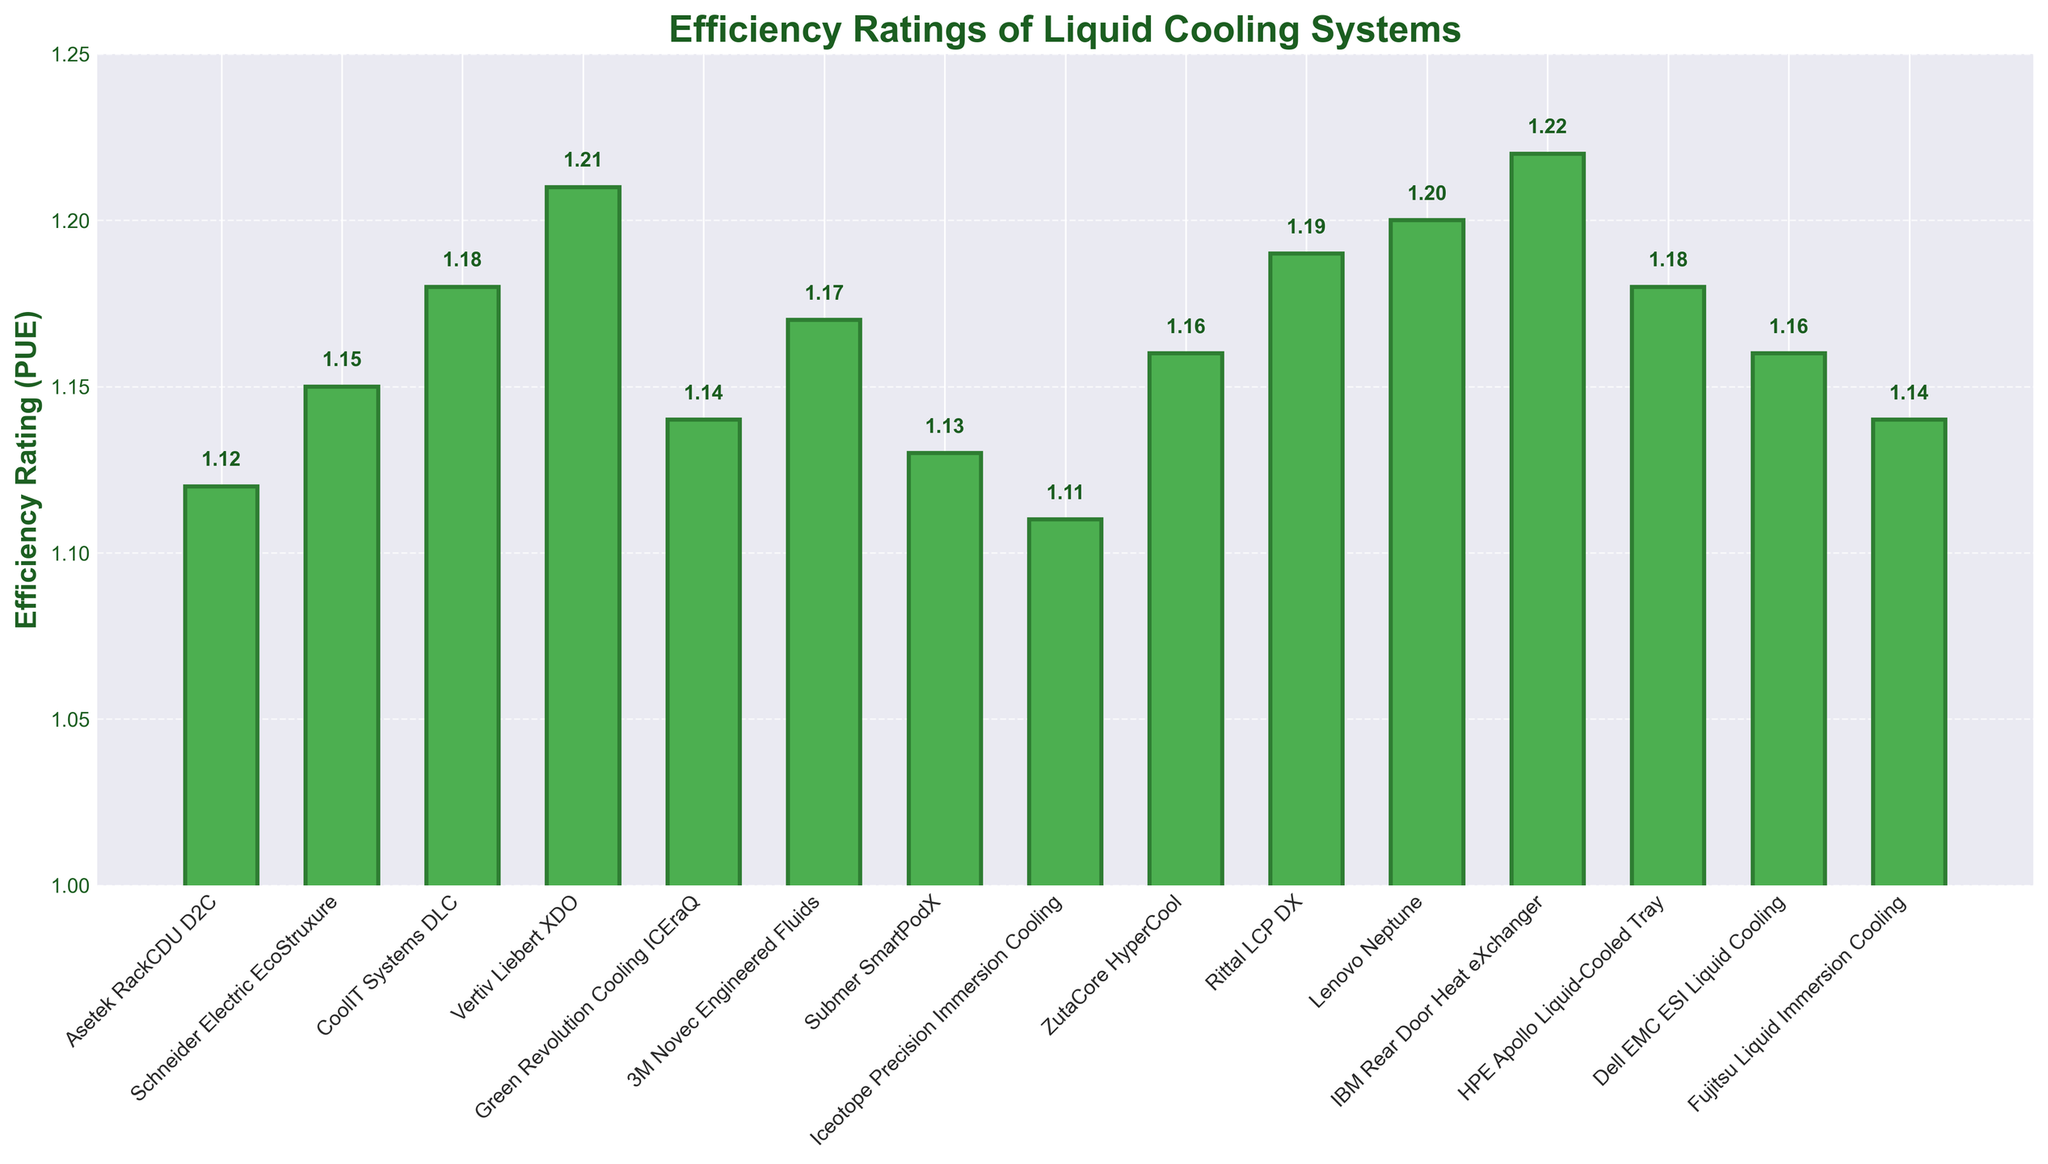Which cooling solution has the lowest PUE rating? The bar with the lowest height in the plot represents the Iceotope Precision Immersion Cooling with an efficiency rating of 1.11. This rating is visually lower than all other bars.
Answer: Iceotope Precision Immersion Cooling Which cooling solutions have a PUE rating lower than 1.15? By visually identifying bars that do not reach the 1.15 mark on the y-axis, it can be observed that Iceotope Precision Immersion Cooling (1.11), Asetek RackCDU D2C (1.12), Submer SmartPodX (1.13), and Green Revolution Cooling ICEraQ (1.14) all have efficiency ratings below 1.15.
Answer: Iceotope Precision Immersion Cooling, Asetek RackCDU D2C, Submer SmartPodX, Green Revolution Cooling ICEraQ Which two cooling solutions have the closest PUE ratings? Looking at the heights of the bars, Schneider Electric EcoStruxure (1.15) and ZutaCore HyperCool (1.16) have PUE ratings very close to each other with a difference of just 0.01.
Answer: Schneider Electric EcoStruxure, ZutaCore HyperCool What's the average PUE rating of CoolIT Systems DLC, HPE Apollo Liquid-Cooled Tray, and Dell EMC ESI Liquid Cooling? Add the PUE ratings of the three solutions: CoolIT Systems DLC (1.18), HPE Apollo Liquid-Cooled Tray (1.18), Dell EMC ESI Liquid Cooling (1.16) and then divide by 3. (1.18 + 1.18 + 1.16) / 3 = 1.173.
Answer: 1.173 Which cooling solution has the most similar efficiency rating to Green Revolution Cooling ICEraQ? The closest rating to Green Revolution Cooling ICEraQ (1.14) is Submer SmartPodX (1.13), which is one step lower but very similar.
Answer: Submer SmartPodX If Lenovo Neptune improves its PUE rating by 0.03, which solution(s) would it then match? Lenovo Neptune's current rating is 1.20. By improving by 0.03, its new rating would be 1.17, matching the PUE rating of 3M Novec Engineered Fluids.
Answer: 3M Novec Engineered Fluids How many cooling solutions have a PUE rating between 1.10 and 1.14 (inclusive)? Count the number of bars whose tops fall within the 1.10 to 1.14 range on the y-axis: Iceotope Precision Immersion Cooling (1.11), Asetek RackCDU D2C (1.12), Submer SmartPodX (1.13), Green Revolution Cooling ICEraQ (1.14), and Fujitsu Liquid Immersion Cooling (1.14). This gives a total of 5 cooling solutions.
Answer: 5 Which cooling solution has the highest PUE rating? The bar with the highest height in the plot represents the IBM Rear Door Heat eXchanger with an efficiency rating of 1.22.
Answer: IBM Rear Door Heat eXchanger 